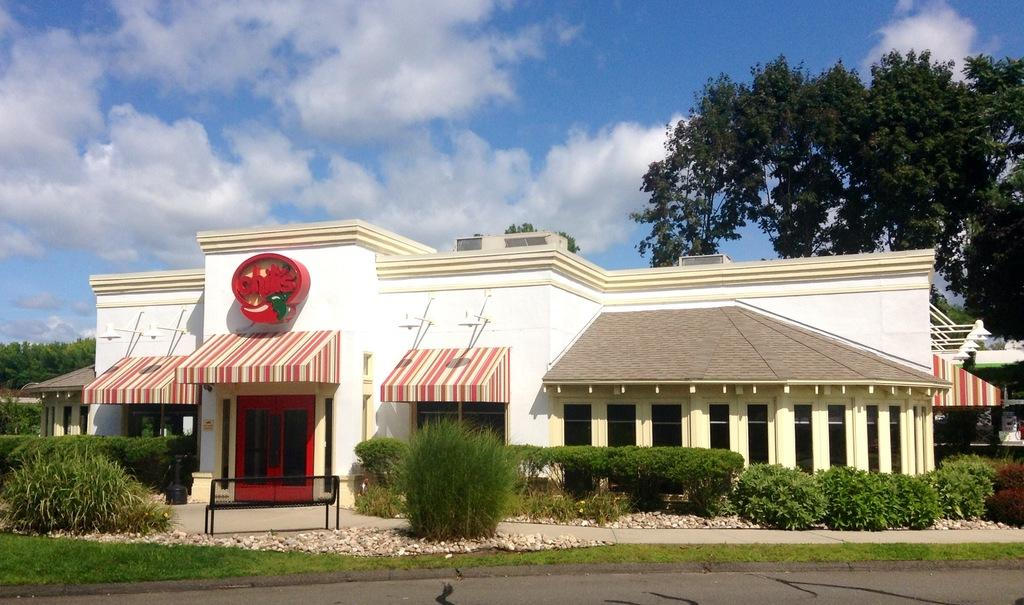<image>
Render a clear and concise summary of the photo. A restaurant with the word chillis on it above a canopy 